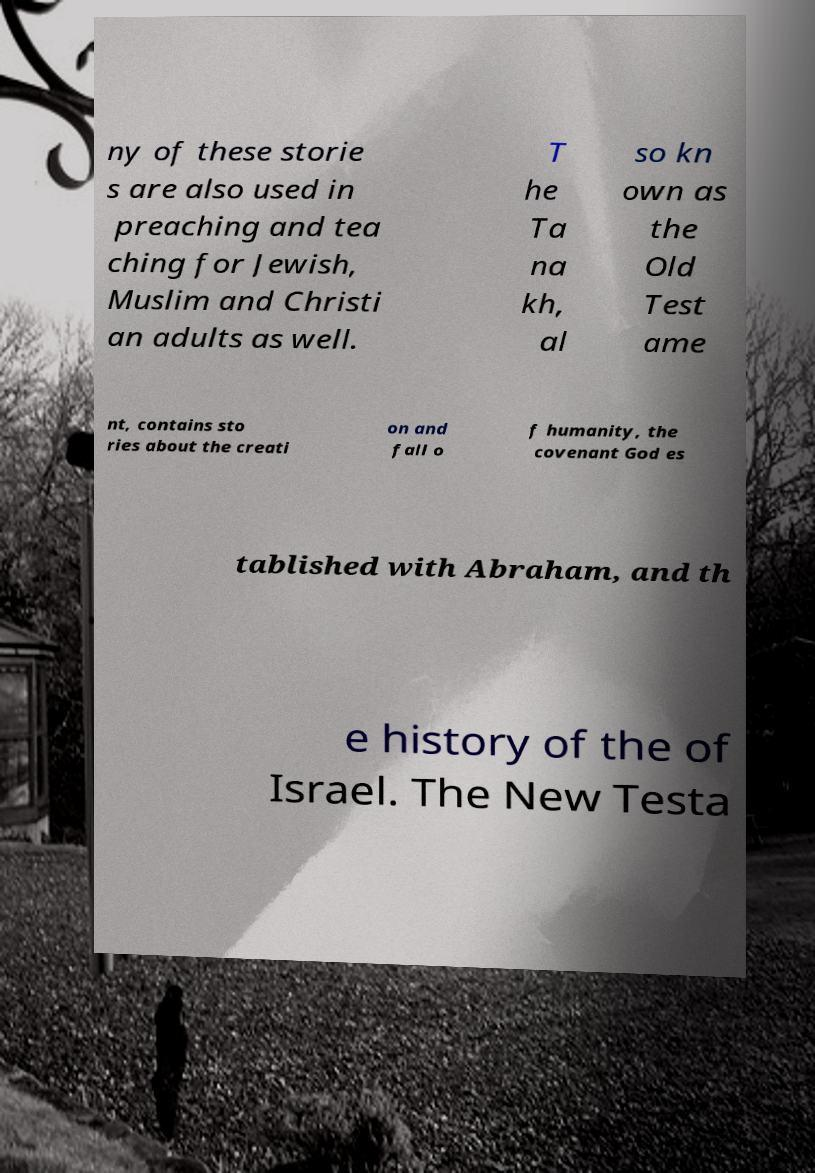There's text embedded in this image that I need extracted. Can you transcribe it verbatim? ny of these storie s are also used in preaching and tea ching for Jewish, Muslim and Christi an adults as well. T he Ta na kh, al so kn own as the Old Test ame nt, contains sto ries about the creati on and fall o f humanity, the covenant God es tablished with Abraham, and th e history of the of Israel. The New Testa 